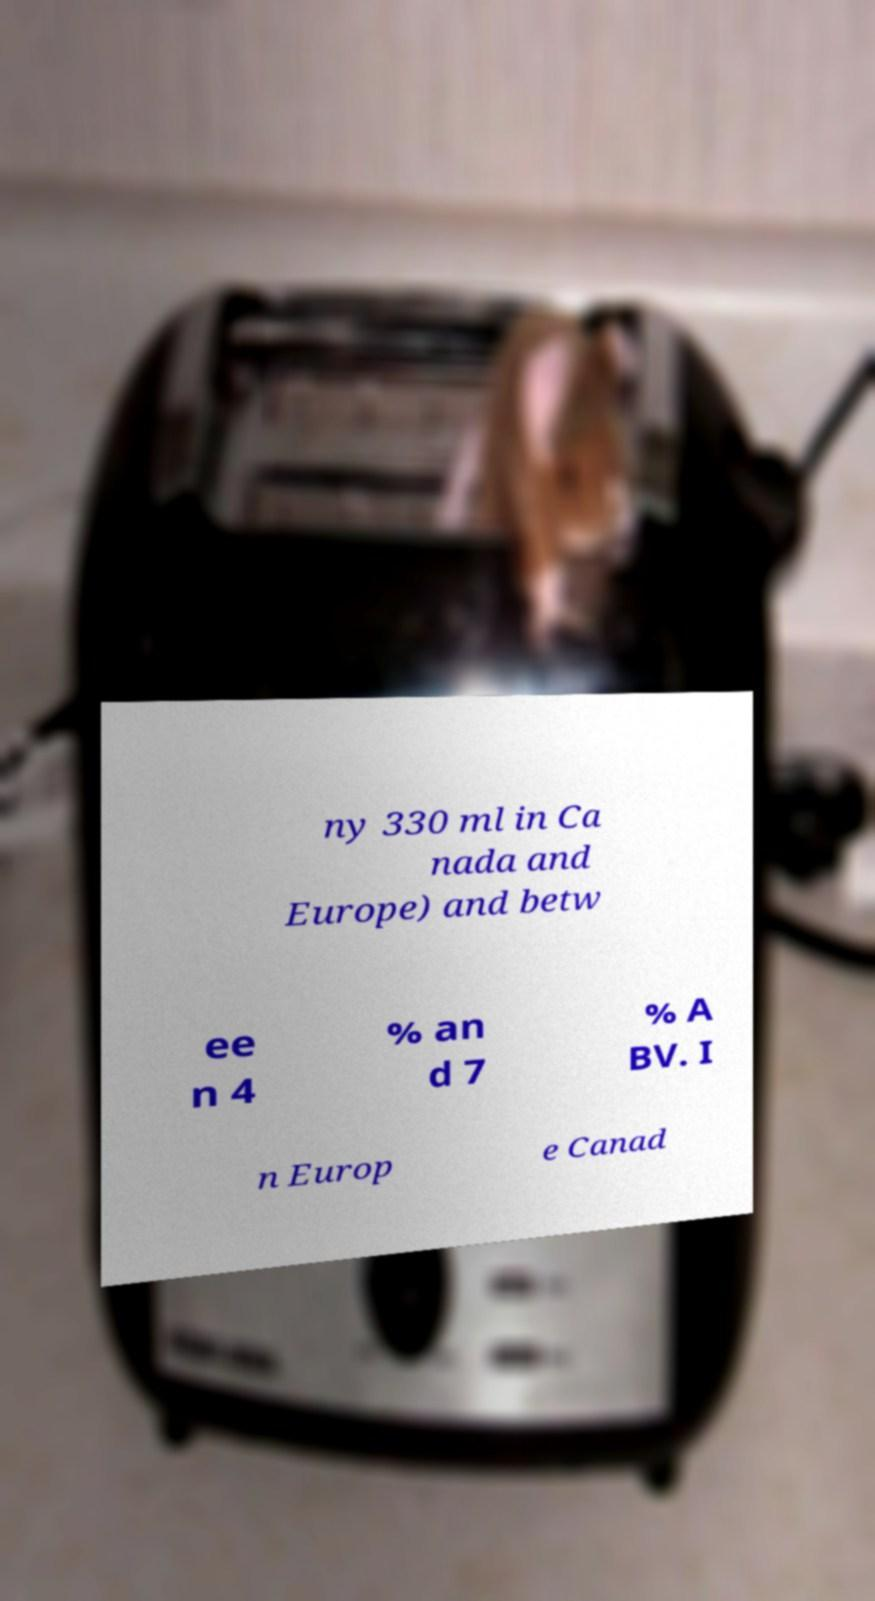What messages or text are displayed in this image? I need them in a readable, typed format. ny 330 ml in Ca nada and Europe) and betw ee n 4 % an d 7 % A BV. I n Europ e Canad 